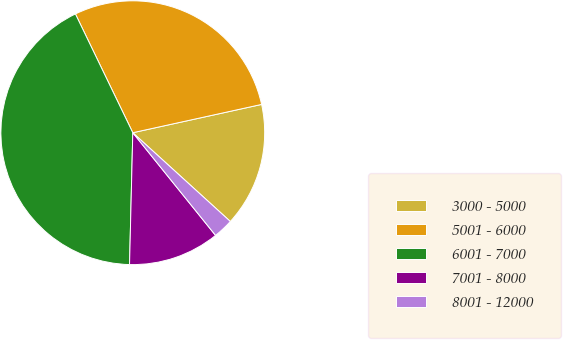Convert chart. <chart><loc_0><loc_0><loc_500><loc_500><pie_chart><fcel>3000 - 5000<fcel>5001 - 6000<fcel>6001 - 7000<fcel>7001 - 8000<fcel>8001 - 12000<nl><fcel>15.19%<fcel>28.72%<fcel>42.44%<fcel>11.19%<fcel>2.45%<nl></chart> 